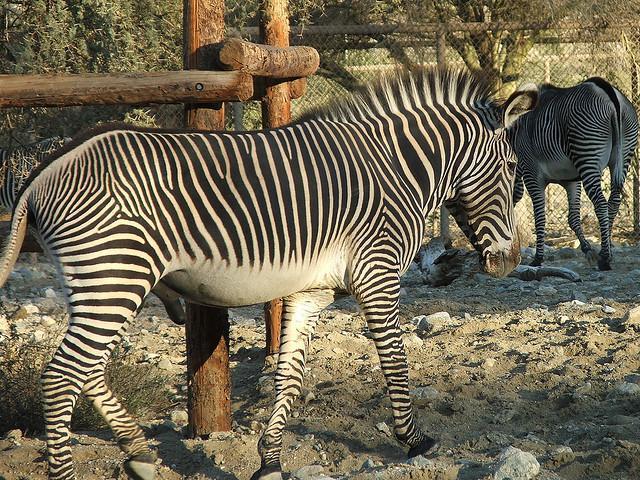How many zebras are there?
Give a very brief answer. 2. 